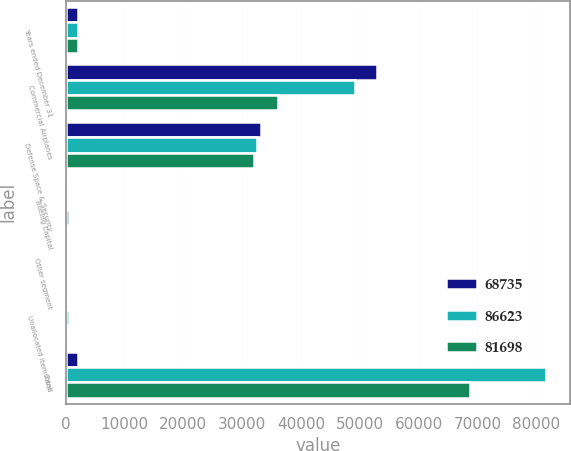Convert chart. <chart><loc_0><loc_0><loc_500><loc_500><stacked_bar_chart><ecel><fcel>Years ended December 31<fcel>Commercial Airplanes<fcel>Defense Space & Security<fcel>Boeing Capital<fcel>Other segment<fcel>Unallocated items and<fcel>Total<nl><fcel>68735<fcel>2013<fcel>52981<fcel>33197<fcel>408<fcel>102<fcel>65<fcel>2011.5<nl><fcel>86623<fcel>2012<fcel>49127<fcel>32607<fcel>468<fcel>106<fcel>610<fcel>81698<nl><fcel>81698<fcel>2011<fcel>36171<fcel>31976<fcel>547<fcel>123<fcel>82<fcel>68735<nl></chart> 